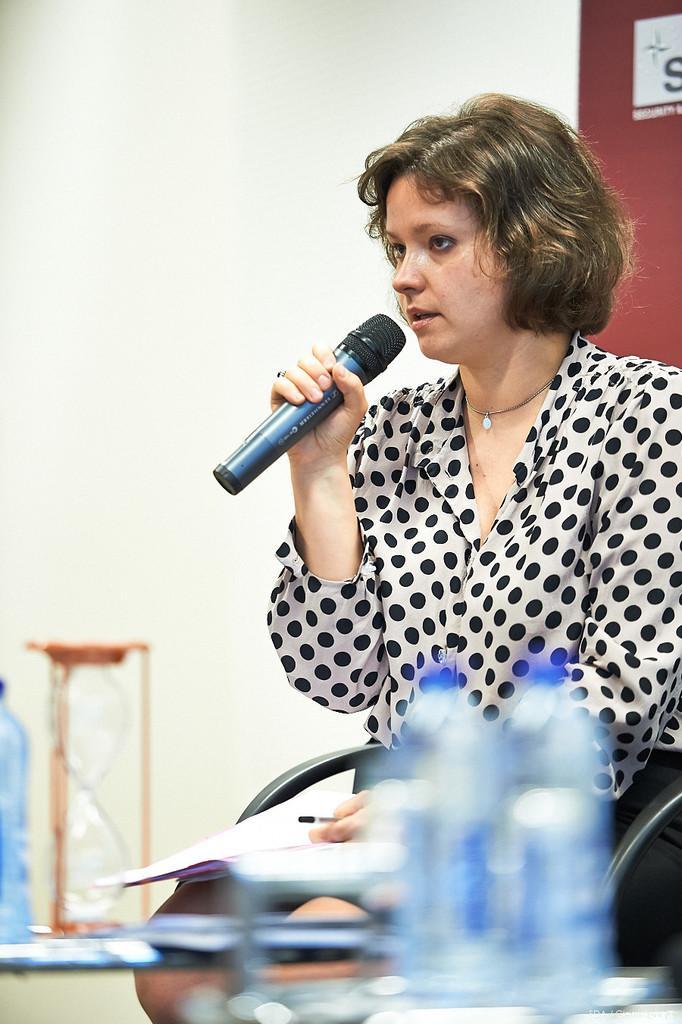Can you describe this image briefly? Here a woman is sitting in the chair and speaking in the microphone she wears a black and white dress. 